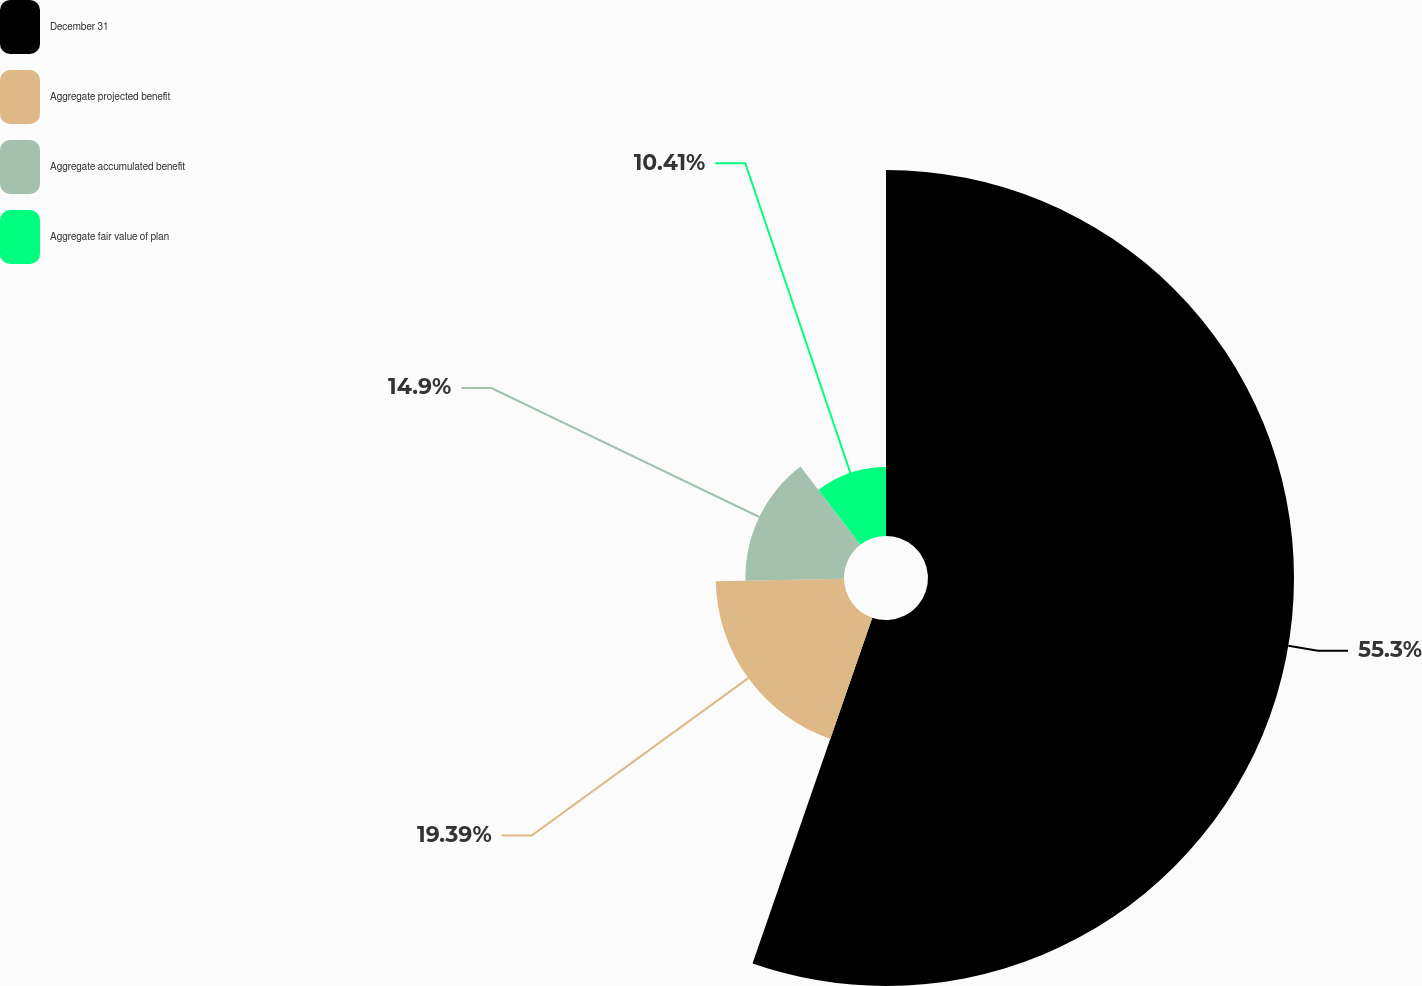<chart> <loc_0><loc_0><loc_500><loc_500><pie_chart><fcel>December 31<fcel>Aggregate projected benefit<fcel>Aggregate accumulated benefit<fcel>Aggregate fair value of plan<nl><fcel>55.31%<fcel>19.39%<fcel>14.9%<fcel>10.41%<nl></chart> 